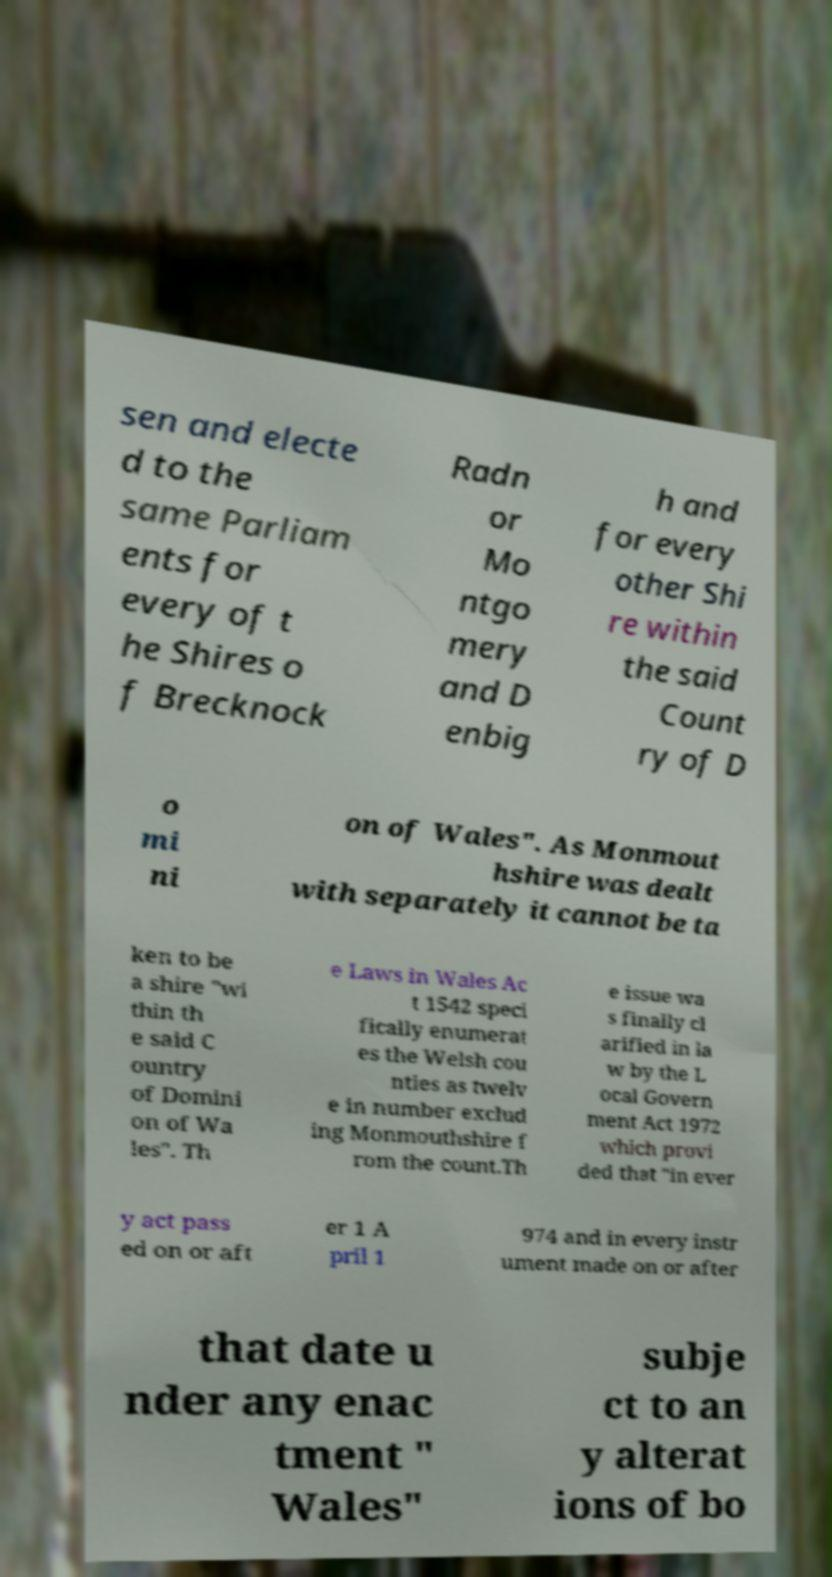Please identify and transcribe the text found in this image. sen and electe d to the same Parliam ents for every of t he Shires o f Brecknock Radn or Mo ntgo mery and D enbig h and for every other Shi re within the said Count ry of D o mi ni on of Wales". As Monmout hshire was dealt with separately it cannot be ta ken to be a shire "wi thin th e said C ountry of Domini on of Wa les". Th e Laws in Wales Ac t 1542 speci fically enumerat es the Welsh cou nties as twelv e in number exclud ing Monmouthshire f rom the count.Th e issue wa s finally cl arified in la w by the L ocal Govern ment Act 1972 which provi ded that "in ever y act pass ed on or aft er 1 A pril 1 974 and in every instr ument made on or after that date u nder any enac tment " Wales" subje ct to an y alterat ions of bo 